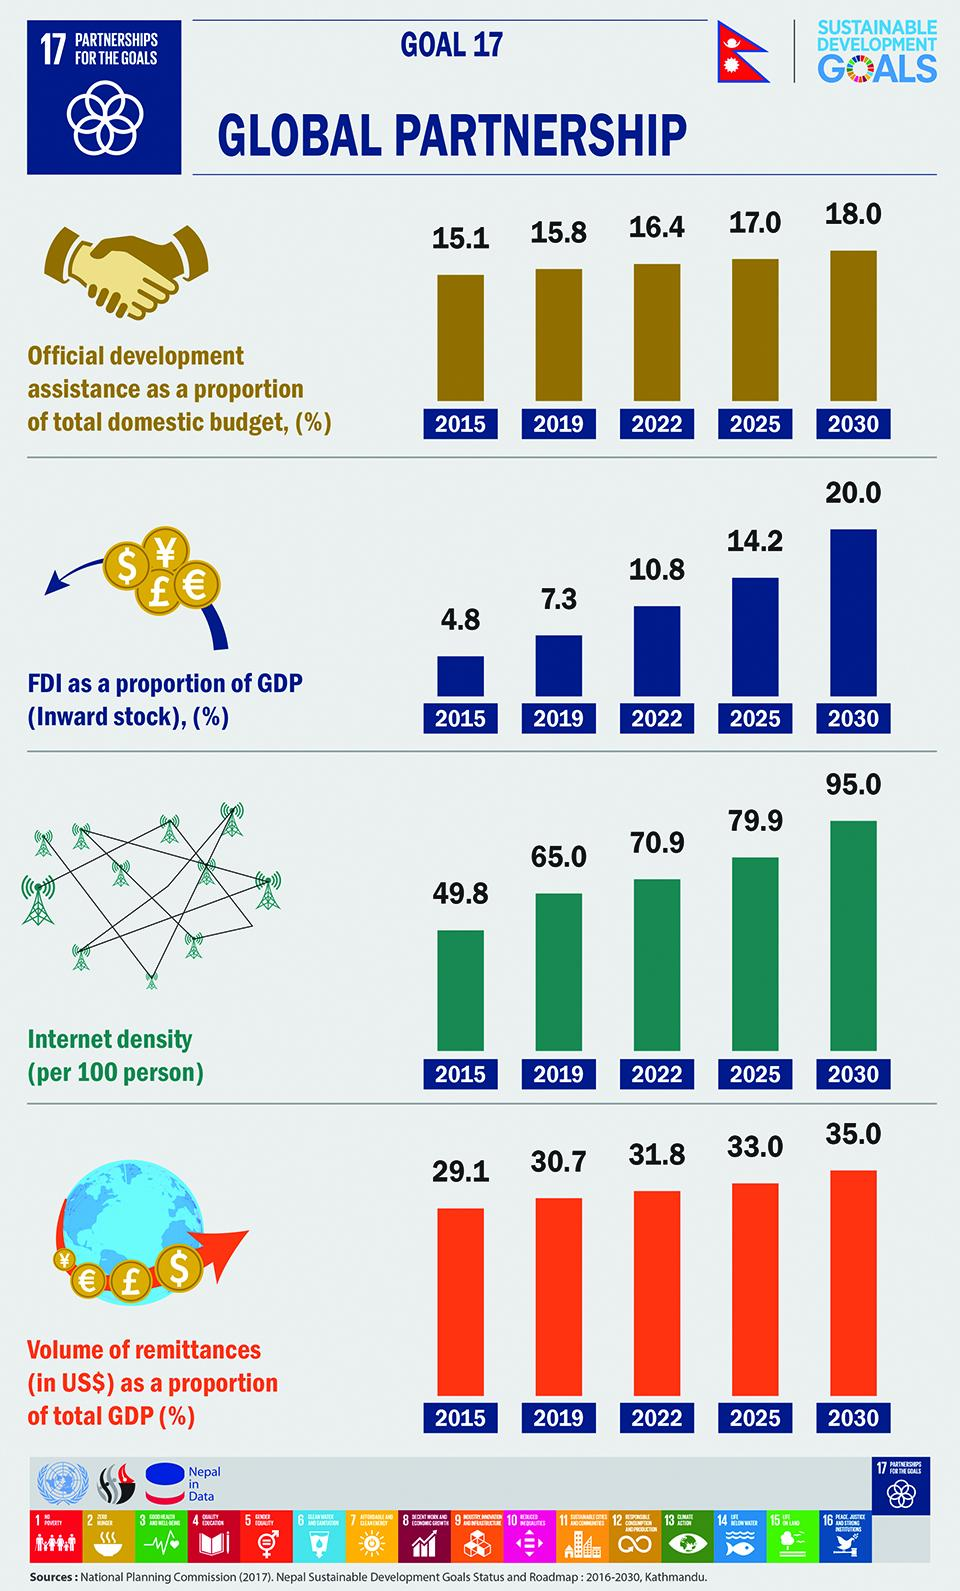Give some essential details in this illustration. What is the combined FDI in 2022 and 2025? In 2022 and 2025, the internet density is projected to be 150.8%. The internet density in 2015 and 2019, taken together, was 114.8%. The volume of remittances in 2022 and 2025, taken together, is 64.8%. In 2015 and 2019, the total amount of Foreign Direct Investment (FDI) taken together was 12.1 billion U.S. dollars. 